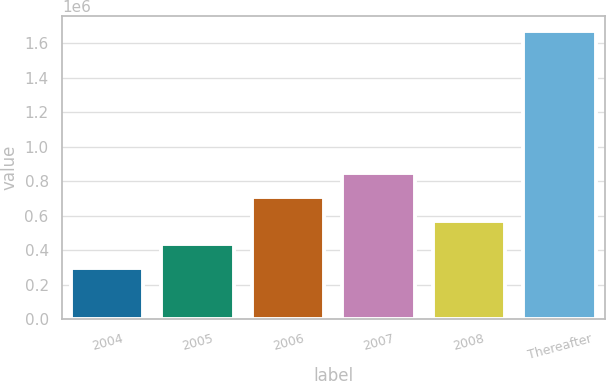<chart> <loc_0><loc_0><loc_500><loc_500><bar_chart><fcel>2004<fcel>2005<fcel>2006<fcel>2007<fcel>2008<fcel>Thereafter<nl><fcel>296184<fcel>433852<fcel>709189<fcel>846857<fcel>571520<fcel>1.67287e+06<nl></chart> 